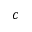Convert formula to latex. <formula><loc_0><loc_0><loc_500><loc_500>c</formula> 